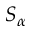Convert formula to latex. <formula><loc_0><loc_0><loc_500><loc_500>S _ { \alpha }</formula> 